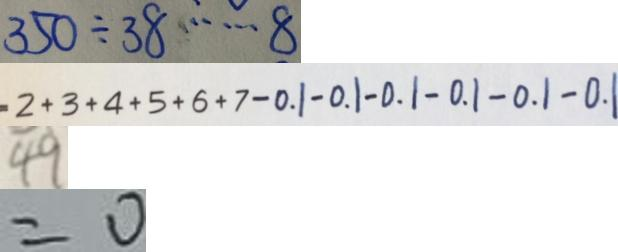<formula> <loc_0><loc_0><loc_500><loc_500>3 5 0 \div 3 8 \cdots 8 
 = 2 + 3 + 4 + 5 + 6 + 7 - 0 . 1 - 0 . 1 - 0 . 1 - 0 . 1 - 0 . 1 - 0 . 1 
 4 9 
 = 0</formula> 